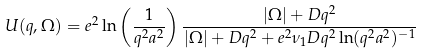Convert formula to latex. <formula><loc_0><loc_0><loc_500><loc_500>U ( q , \Omega ) = e ^ { 2 } \ln \left ( \frac { 1 } { q ^ { 2 } a ^ { 2 } } \right ) \frac { | \Omega | + D q ^ { 2 } } { | \Omega | + D q ^ { 2 } + e ^ { 2 } \nu _ { 1 } D q ^ { 2 } \ln ( q ^ { 2 } a ^ { 2 } ) ^ { - 1 } }</formula> 